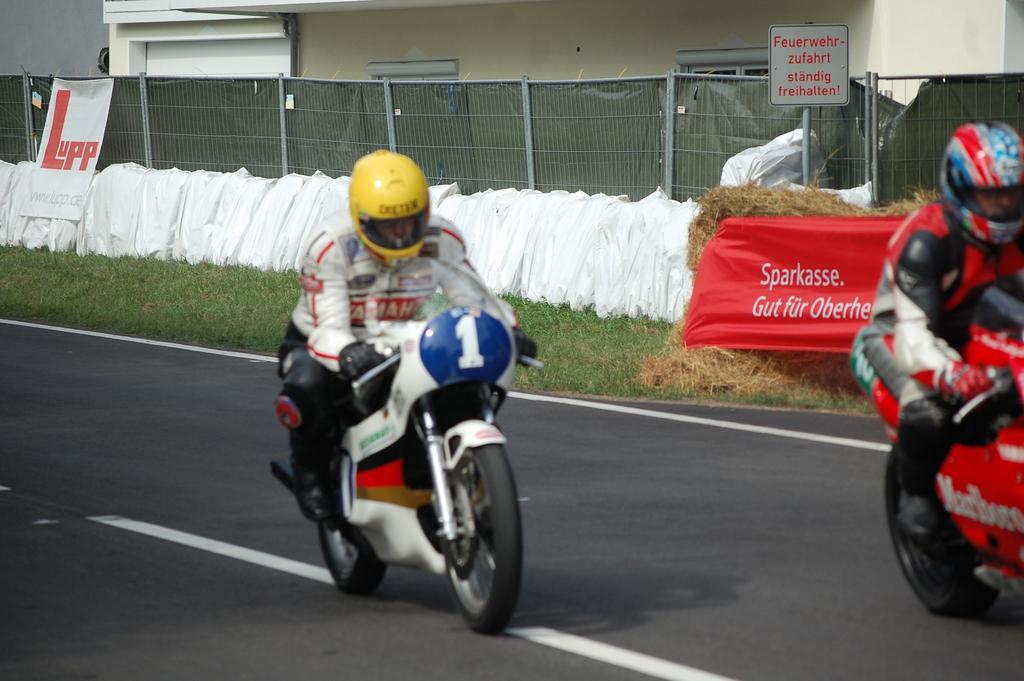Describe this image in one or two sentences. In the middle of this image, there is a person in a white color jacket wearing a yellow color helmet and riding a bike on a road on which there are white color lines. On the right side, there is a person in a red color jacket riding a red color bike on the road. In the background, there is a building, a fence, there are grass, banners and white color objects. 